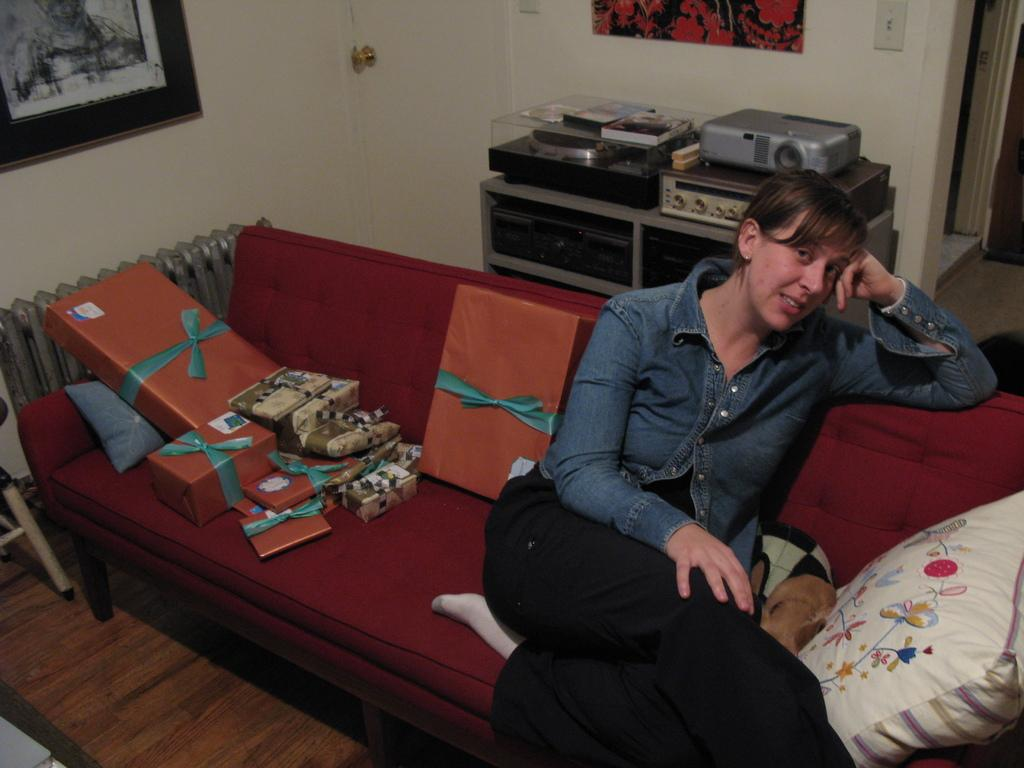What is the woman in the image doing? The woman is seated on the sofa in the image. What else can be seen in the image besides the woman? There are packed gifts in the image. Is there any decoration or item on the wall in the image? Yes, there is a photo frame on the wall in the image. What type of sign can be seen in the image? There is no sign present in the image. Is there a cannon visible in the image? No, there is no cannon present in the image. 